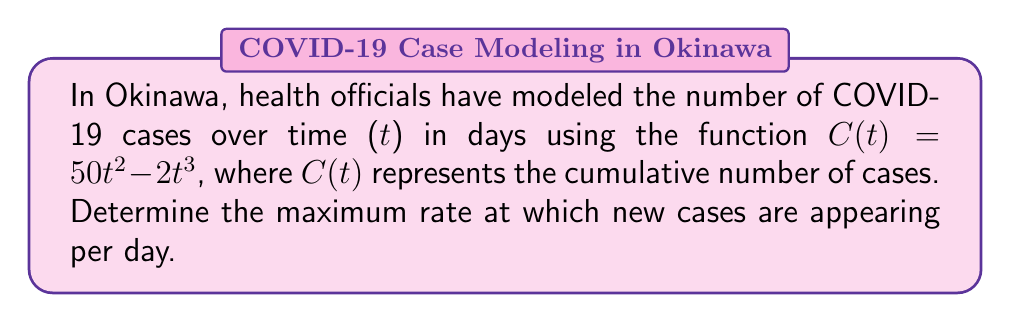Help me with this question. To find the maximum rate of new cases appearing per day, we need to follow these steps:

1) First, we need to find the rate of new cases appearing. This is given by the derivative of $C(t)$ with respect to $t$:

   $\frac{dC}{dt} = C'(t) = 100t - 6t^2$

2) This derivative represents the rate of new cases per day at any given time $t$.

3) To find the maximum rate, we need to find the maximum value of this derivative function. We can do this by finding where its derivative equals zero:

   $\frac{d}{dt}(C'(t)) = 100 - 12t$

4) Set this equal to zero and solve for $t$:

   $100 - 12t = 0$
   $-12t = -100$
   $t = \frac{25}{3}$

5) This critical point could be a maximum or minimum. To confirm it's a maximum, we can check the second derivative:

   $\frac{d^2}{dt^2}(C'(t)) = -12$

   Since this is negative, we confirm that $t = \frac{25}{3}$ gives a maximum.

6) Now, we can find the maximum rate by plugging this $t$ value back into $C'(t)$:

   $C'(\frac{25}{3}) = 100(\frac{25}{3}) - 6(\frac{25}{3})^2$
                     $= \frac{2500}{3} - 6(\frac{625}{9})$
                     $= \frac{2500}{3} - \frac{3750}{9}$
                     $= \frac{7500}{9} - \frac{3750}{9}$
                     $= \frac{3750}{9}$
                     $= 416.67$

Therefore, the maximum rate of new cases appearing is approximately 416.67 cases per day.
Answer: 416.67 cases per day 